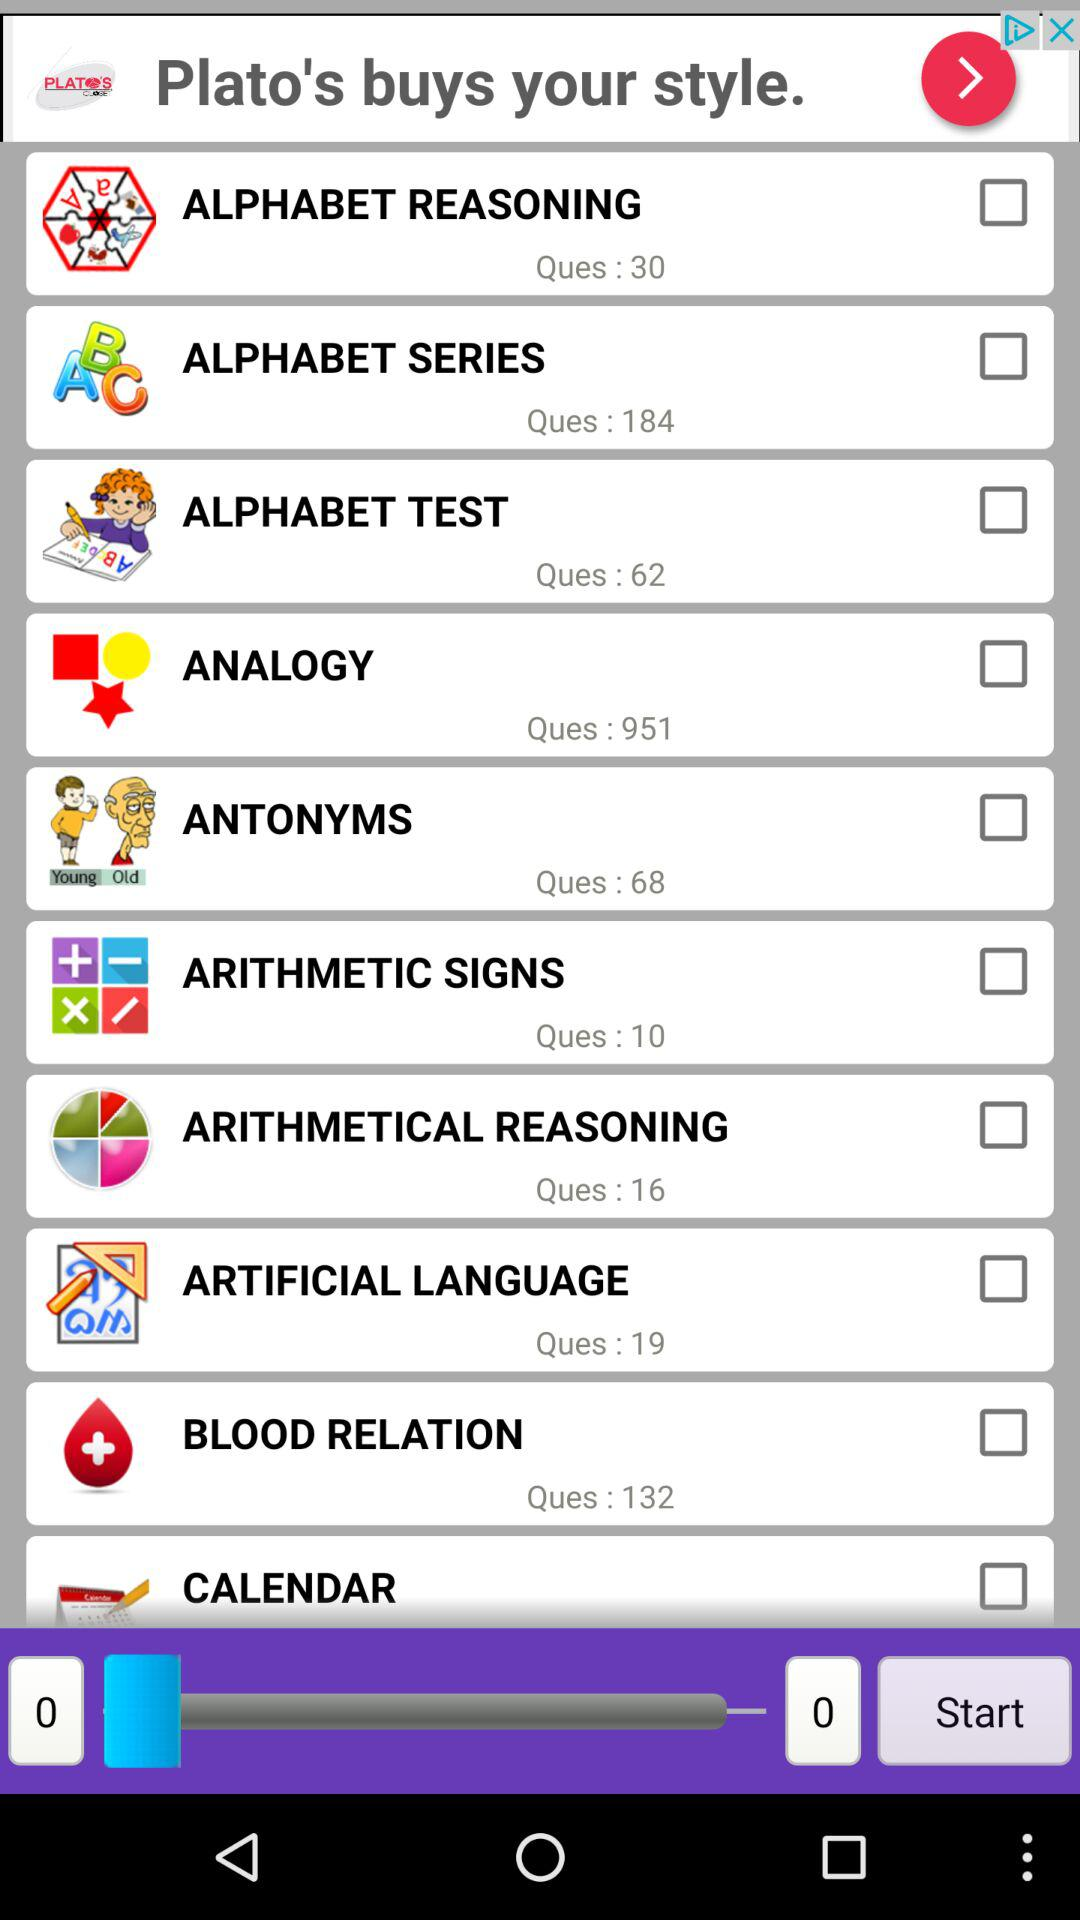How many questions are there in "BLOOD RELATION"? There are 132 questions in "BLOOD RELATION". 